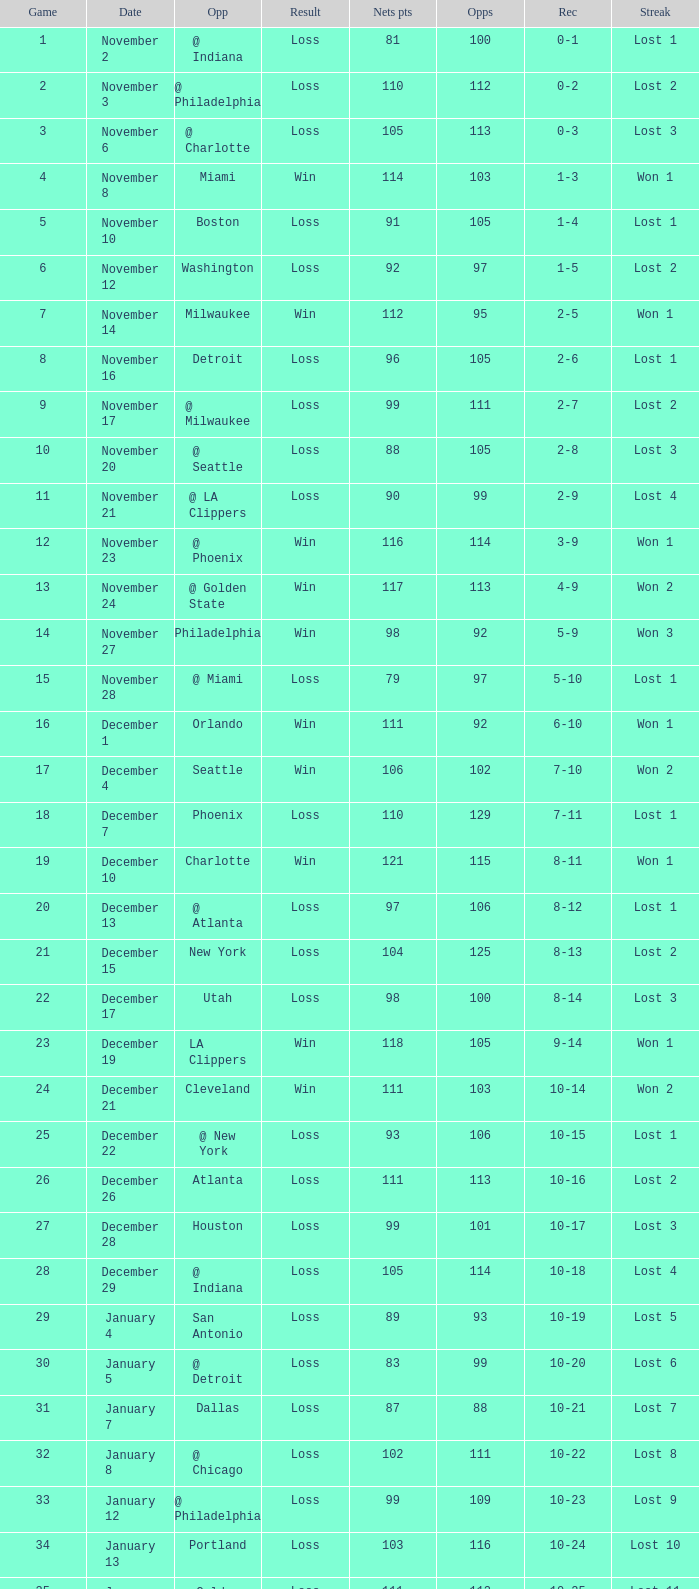In which game did the opponent score more than 103 and the record was 1-3? None. Write the full table. {'header': ['Game', 'Date', 'Opp', 'Result', 'Nets pts', 'Opps', 'Rec', 'Streak'], 'rows': [['1', 'November 2', '@ Indiana', 'Loss', '81', '100', '0-1', 'Lost 1'], ['2', 'November 3', '@ Philadelphia', 'Loss', '110', '112', '0-2', 'Lost 2'], ['3', 'November 6', '@ Charlotte', 'Loss', '105', '113', '0-3', 'Lost 3'], ['4', 'November 8', 'Miami', 'Win', '114', '103', '1-3', 'Won 1'], ['5', 'November 10', 'Boston', 'Loss', '91', '105', '1-4', 'Lost 1'], ['6', 'November 12', 'Washington', 'Loss', '92', '97', '1-5', 'Lost 2'], ['7', 'November 14', 'Milwaukee', 'Win', '112', '95', '2-5', 'Won 1'], ['8', 'November 16', 'Detroit', 'Loss', '96', '105', '2-6', 'Lost 1'], ['9', 'November 17', '@ Milwaukee', 'Loss', '99', '111', '2-7', 'Lost 2'], ['10', 'November 20', '@ Seattle', 'Loss', '88', '105', '2-8', 'Lost 3'], ['11', 'November 21', '@ LA Clippers', 'Loss', '90', '99', '2-9', 'Lost 4'], ['12', 'November 23', '@ Phoenix', 'Win', '116', '114', '3-9', 'Won 1'], ['13', 'November 24', '@ Golden State', 'Win', '117', '113', '4-9', 'Won 2'], ['14', 'November 27', 'Philadelphia', 'Win', '98', '92', '5-9', 'Won 3'], ['15', 'November 28', '@ Miami', 'Loss', '79', '97', '5-10', 'Lost 1'], ['16', 'December 1', 'Orlando', 'Win', '111', '92', '6-10', 'Won 1'], ['17', 'December 4', 'Seattle', 'Win', '106', '102', '7-10', 'Won 2'], ['18', 'December 7', 'Phoenix', 'Loss', '110', '129', '7-11', 'Lost 1'], ['19', 'December 10', 'Charlotte', 'Win', '121', '115', '8-11', 'Won 1'], ['20', 'December 13', '@ Atlanta', 'Loss', '97', '106', '8-12', 'Lost 1'], ['21', 'December 15', 'New York', 'Loss', '104', '125', '8-13', 'Lost 2'], ['22', 'December 17', 'Utah', 'Loss', '98', '100', '8-14', 'Lost 3'], ['23', 'December 19', 'LA Clippers', 'Win', '118', '105', '9-14', 'Won 1'], ['24', 'December 21', 'Cleveland', 'Win', '111', '103', '10-14', 'Won 2'], ['25', 'December 22', '@ New York', 'Loss', '93', '106', '10-15', 'Lost 1'], ['26', 'December 26', 'Atlanta', 'Loss', '111', '113', '10-16', 'Lost 2'], ['27', 'December 28', 'Houston', 'Loss', '99', '101', '10-17', 'Lost 3'], ['28', 'December 29', '@ Indiana', 'Loss', '105', '114', '10-18', 'Lost 4'], ['29', 'January 4', 'San Antonio', 'Loss', '89', '93', '10-19', 'Lost 5'], ['30', 'January 5', '@ Detroit', 'Loss', '83', '99', '10-20', 'Lost 6'], ['31', 'January 7', 'Dallas', 'Loss', '87', '88', '10-21', 'Lost 7'], ['32', 'January 8', '@ Chicago', 'Loss', '102', '111', '10-22', 'Lost 8'], ['33', 'January 12', '@ Philadelphia', 'Loss', '99', '109', '10-23', 'Lost 9'], ['34', 'January 13', 'Portland', 'Loss', '103', '116', '10-24', 'Lost 10'], ['35', 'January 15', 'Golden State', 'Loss', '111', '112', '10-25', 'Lost 11'], ['36', 'January 18', '@ Boston', 'Win', '111', '106', '11-25', 'Won 1'], ['37', 'January 19', '@ Atlanta', 'Loss', '84', '114', '11-26', 'Lost 1'], ['38', 'January 22', '@ Charlotte', 'Win', '92', '90', '12-26', 'Won 1'], ['39', 'January 23', 'Chicago', 'Win', '99', '95', '13-26', 'Won 2'], ['40', 'January 25', 'LA Lakers', 'Loss', '103', '108', '13-27', 'Lost 1'], ['41', 'January 26', '@ Miami', 'Win', '127', '105', '14-27', 'Won 1'], ['42', 'January 28', '@ Sacramento', 'Loss', '83', '101', '14-28', 'Lost 1'], ['43', 'January 29', '@ LA Lakers', 'Loss', '89', '110', '14-29', 'Lost 2'], ['44', 'January 31', '@ Denver', 'Loss', '119', '123', '14-30', 'Lost 3'], ['45', 'February 2', '@ Utah', 'Loss', '103', '111', '14-31', 'Lost 4'], ['46', 'February 4', '@ Portland', 'Loss', '102', '117', '14-32', 'Lost 5'], ['47', 'February 6', 'Miami', 'Loss', '119', '134', '14-33', 'Lost 6'], ['48', 'February 7', '@ Washington', 'Loss', '117', '124', '14-34', 'Lost 7'], ['49', 'February 13', 'Atlanta', 'Win', '140', '106', '15-34', 'Won 1'], ['50', 'February 15', 'Denver', 'Win', '138', '110', '16-34', 'Won 2'], ['51', 'February 16', '@ Chicago', 'Loss', '87', '99', '16-35', 'Lost 1'], ['52', 'February 19', 'Sacramento', 'Win', '97', '83', '17-35', 'Won 1'], ['53', 'February 22', '@ Boston', 'Loss', '99', '111', '17-36', 'Lost 1'], ['54', 'February 23', 'Philadelphia', 'Loss', '90', '103', '17-37', 'Lost 2'], ['55', 'February 26', 'Indiana', 'Win', '129', '104', '18-37', 'Won 1'], ['56', 'February 28', 'Milwaukee', 'Win', '98', '93', '19-37', 'Won 2'], ['57', 'March 2', 'New York', 'Loss', '105', '115', '19-38', 'Lost 1'], ['58', 'March 4', '@ Dallas', 'Loss', '100', '102', '19-39', 'Lost 2'], ['59', 'March 5', '@ Houston', 'Loss', '100', '112', '19-40', 'Lost 3'], ['60', 'March 7', '@ San Antonio', 'Loss', '99', '111', '19-41', 'Lost 4'], ['61', 'March 10', '@ Miami', 'Loss', '88', '101', '19-42', 'Lost 5'], ['62', 'March 11', '@ New York', 'Loss', '85', '90', '19-43', 'Lost 6'], ['63', 'March 14', 'Detroit', 'Win', '118', '110', '20-43', 'Won 1'], ['64', 'March 16', 'Washington', 'Win', '110', '86', '21-43', 'Won 2'], ['65', 'March 17', 'Charlotte', 'Loss', '108', '121', '21-44', 'Lost 1'], ['66', 'March 20', 'Minnesota', 'Win', '118', '111', '22-44', 'Won 1'], ['67', 'March 22', '@ Detroit', 'Loss', '93', '109', '22-45', 'Lost 1'], ['68', 'March 23', '@ Cleveland', 'Loss', '82', '108', '22-46', 'Lost 2'], ['69', 'March 25', '@ Washington', 'Loss', '106', '113', '22-47', 'Lost 3'], ['70', 'March 26', 'Philadelphia', 'Win', '98', '95', '23-47', 'Won 1'], ['71', 'March 28', 'Chicago', 'Loss', '94', '128', '23-48', 'Lost 1'], ['72', 'March 30', 'New York', 'Loss', '117', '130', '23-49', 'Lost 2'], ['73', 'April 2', 'Boston', 'Loss', '77', '94', '23-50', 'Lost 3'], ['74', 'April 4', '@ Boston', 'Loss', '104', '123', '23-51', 'Lost 4'], ['75', 'April 6', '@ Milwaukee', 'Loss', '114', '133', '23-52', 'Lost 5'], ['76', 'April 9', '@ Minnesota', 'Loss', '89', '109', '23-53', 'Lost 6'], ['77', 'April 12', 'Cleveland', 'Win', '104', '103', '24-53', 'Won 1'], ['78', 'April 13', '@ Cleveland', 'Loss', '98', '102', '24-54', 'Lost 1'], ['79', 'April 16', 'Indiana', 'Loss', '126', '132', '24-55', 'Lost 2'], ['80', 'April 18', '@ Washington', 'Win', '108', '103', '25-55', 'Won 1'], ['81', 'April 20', 'Miami', 'Win', '118', '103', '26-55', 'Won 2'], ['82', 'April 21', '@ Orlando', 'Loss', '110', '120', '26-56', 'Lost 1']]} 